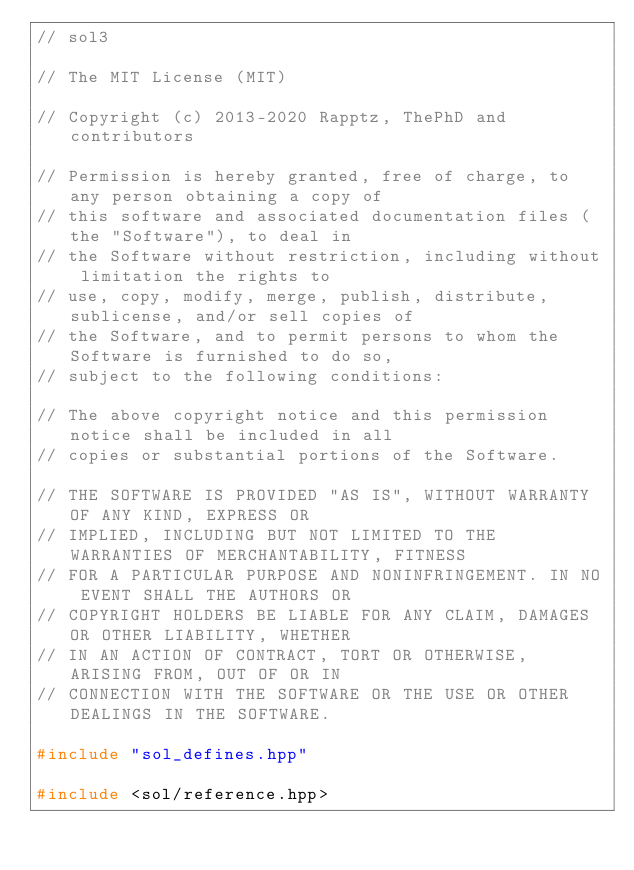Convert code to text. <code><loc_0><loc_0><loc_500><loc_500><_C++_>// sol3

// The MIT License (MIT)

// Copyright (c) 2013-2020 Rapptz, ThePhD and contributors

// Permission is hereby granted, free of charge, to any person obtaining a copy of
// this software and associated documentation files (the "Software"), to deal in
// the Software without restriction, including without limitation the rights to
// use, copy, modify, merge, publish, distribute, sublicense, and/or sell copies of
// the Software, and to permit persons to whom the Software is furnished to do so,
// subject to the following conditions:

// The above copyright notice and this permission notice shall be included in all
// copies or substantial portions of the Software.

// THE SOFTWARE IS PROVIDED "AS IS", WITHOUT WARRANTY OF ANY KIND, EXPRESS OR
// IMPLIED, INCLUDING BUT NOT LIMITED TO THE WARRANTIES OF MERCHANTABILITY, FITNESS
// FOR A PARTICULAR PURPOSE AND NONINFRINGEMENT. IN NO EVENT SHALL THE AUTHORS OR
// COPYRIGHT HOLDERS BE LIABLE FOR ANY CLAIM, DAMAGES OR OTHER LIABILITY, WHETHER
// IN AN ACTION OF CONTRACT, TORT OR OTHERWISE, ARISING FROM, OUT OF OR IN
// CONNECTION WITH THE SOFTWARE OR THE USE OR OTHER DEALINGS IN THE SOFTWARE.

#include "sol_defines.hpp"

#include <sol/reference.hpp>
</code> 